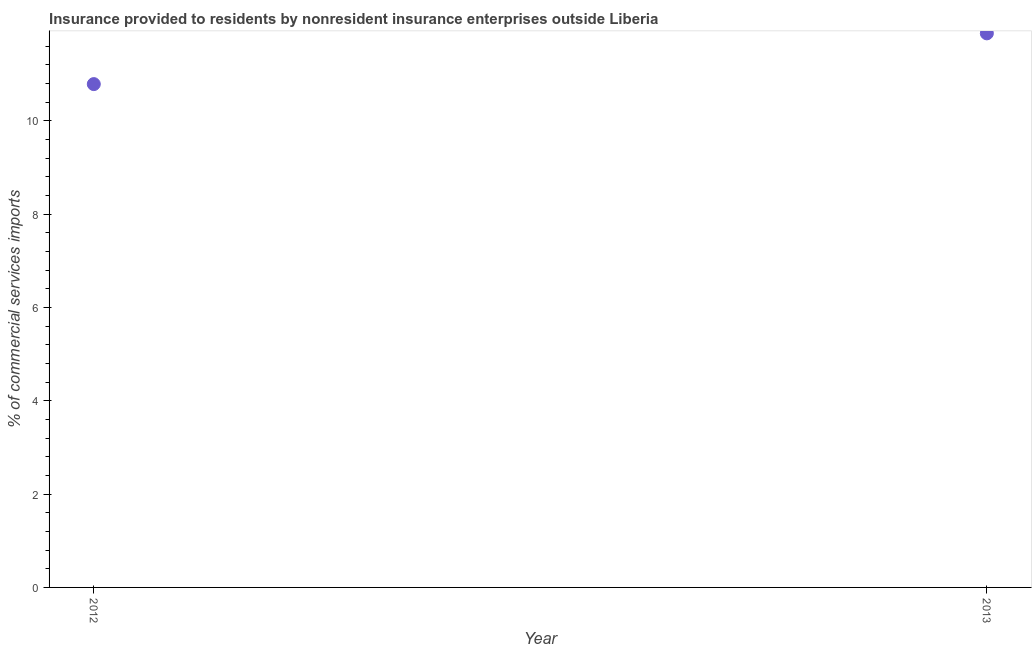What is the insurance provided by non-residents in 2013?
Your answer should be compact. 11.88. Across all years, what is the maximum insurance provided by non-residents?
Your response must be concise. 11.88. Across all years, what is the minimum insurance provided by non-residents?
Give a very brief answer. 10.79. What is the sum of the insurance provided by non-residents?
Give a very brief answer. 22.67. What is the difference between the insurance provided by non-residents in 2012 and 2013?
Your answer should be compact. -1.09. What is the average insurance provided by non-residents per year?
Offer a very short reply. 11.33. What is the median insurance provided by non-residents?
Make the answer very short. 11.33. Do a majority of the years between 2013 and 2012 (inclusive) have insurance provided by non-residents greater than 5.2 %?
Provide a succinct answer. No. What is the ratio of the insurance provided by non-residents in 2012 to that in 2013?
Provide a succinct answer. 0.91. Is the insurance provided by non-residents in 2012 less than that in 2013?
Your answer should be very brief. Yes. In how many years, is the insurance provided by non-residents greater than the average insurance provided by non-residents taken over all years?
Offer a very short reply. 1. Does the insurance provided by non-residents monotonically increase over the years?
Offer a very short reply. Yes. What is the difference between two consecutive major ticks on the Y-axis?
Provide a short and direct response. 2. Does the graph contain any zero values?
Provide a succinct answer. No. Does the graph contain grids?
Give a very brief answer. No. What is the title of the graph?
Offer a very short reply. Insurance provided to residents by nonresident insurance enterprises outside Liberia. What is the label or title of the X-axis?
Your answer should be compact. Year. What is the label or title of the Y-axis?
Give a very brief answer. % of commercial services imports. What is the % of commercial services imports in 2012?
Offer a terse response. 10.79. What is the % of commercial services imports in 2013?
Your answer should be very brief. 11.88. What is the difference between the % of commercial services imports in 2012 and 2013?
Your response must be concise. -1.09. What is the ratio of the % of commercial services imports in 2012 to that in 2013?
Your response must be concise. 0.91. 